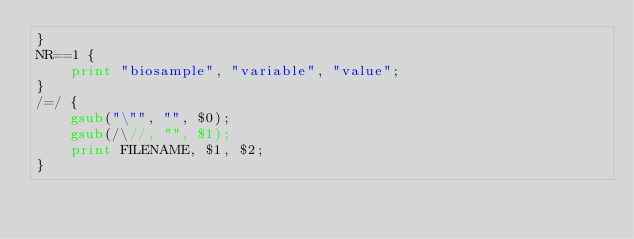Convert code to text. <code><loc_0><loc_0><loc_500><loc_500><_Awk_>}
NR==1 {
	print "biosample", "variable", "value";
}
/=/ {
	gsub("\"", "", $0);
	gsub(/\//, "", $1);
	print FILENAME, $1, $2;
}
</code> 